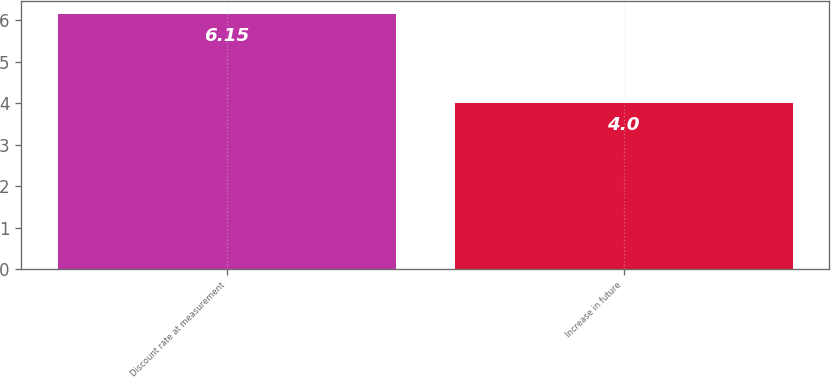<chart> <loc_0><loc_0><loc_500><loc_500><bar_chart><fcel>Discount rate at measurement<fcel>Increase in future<nl><fcel>6.15<fcel>4<nl></chart> 